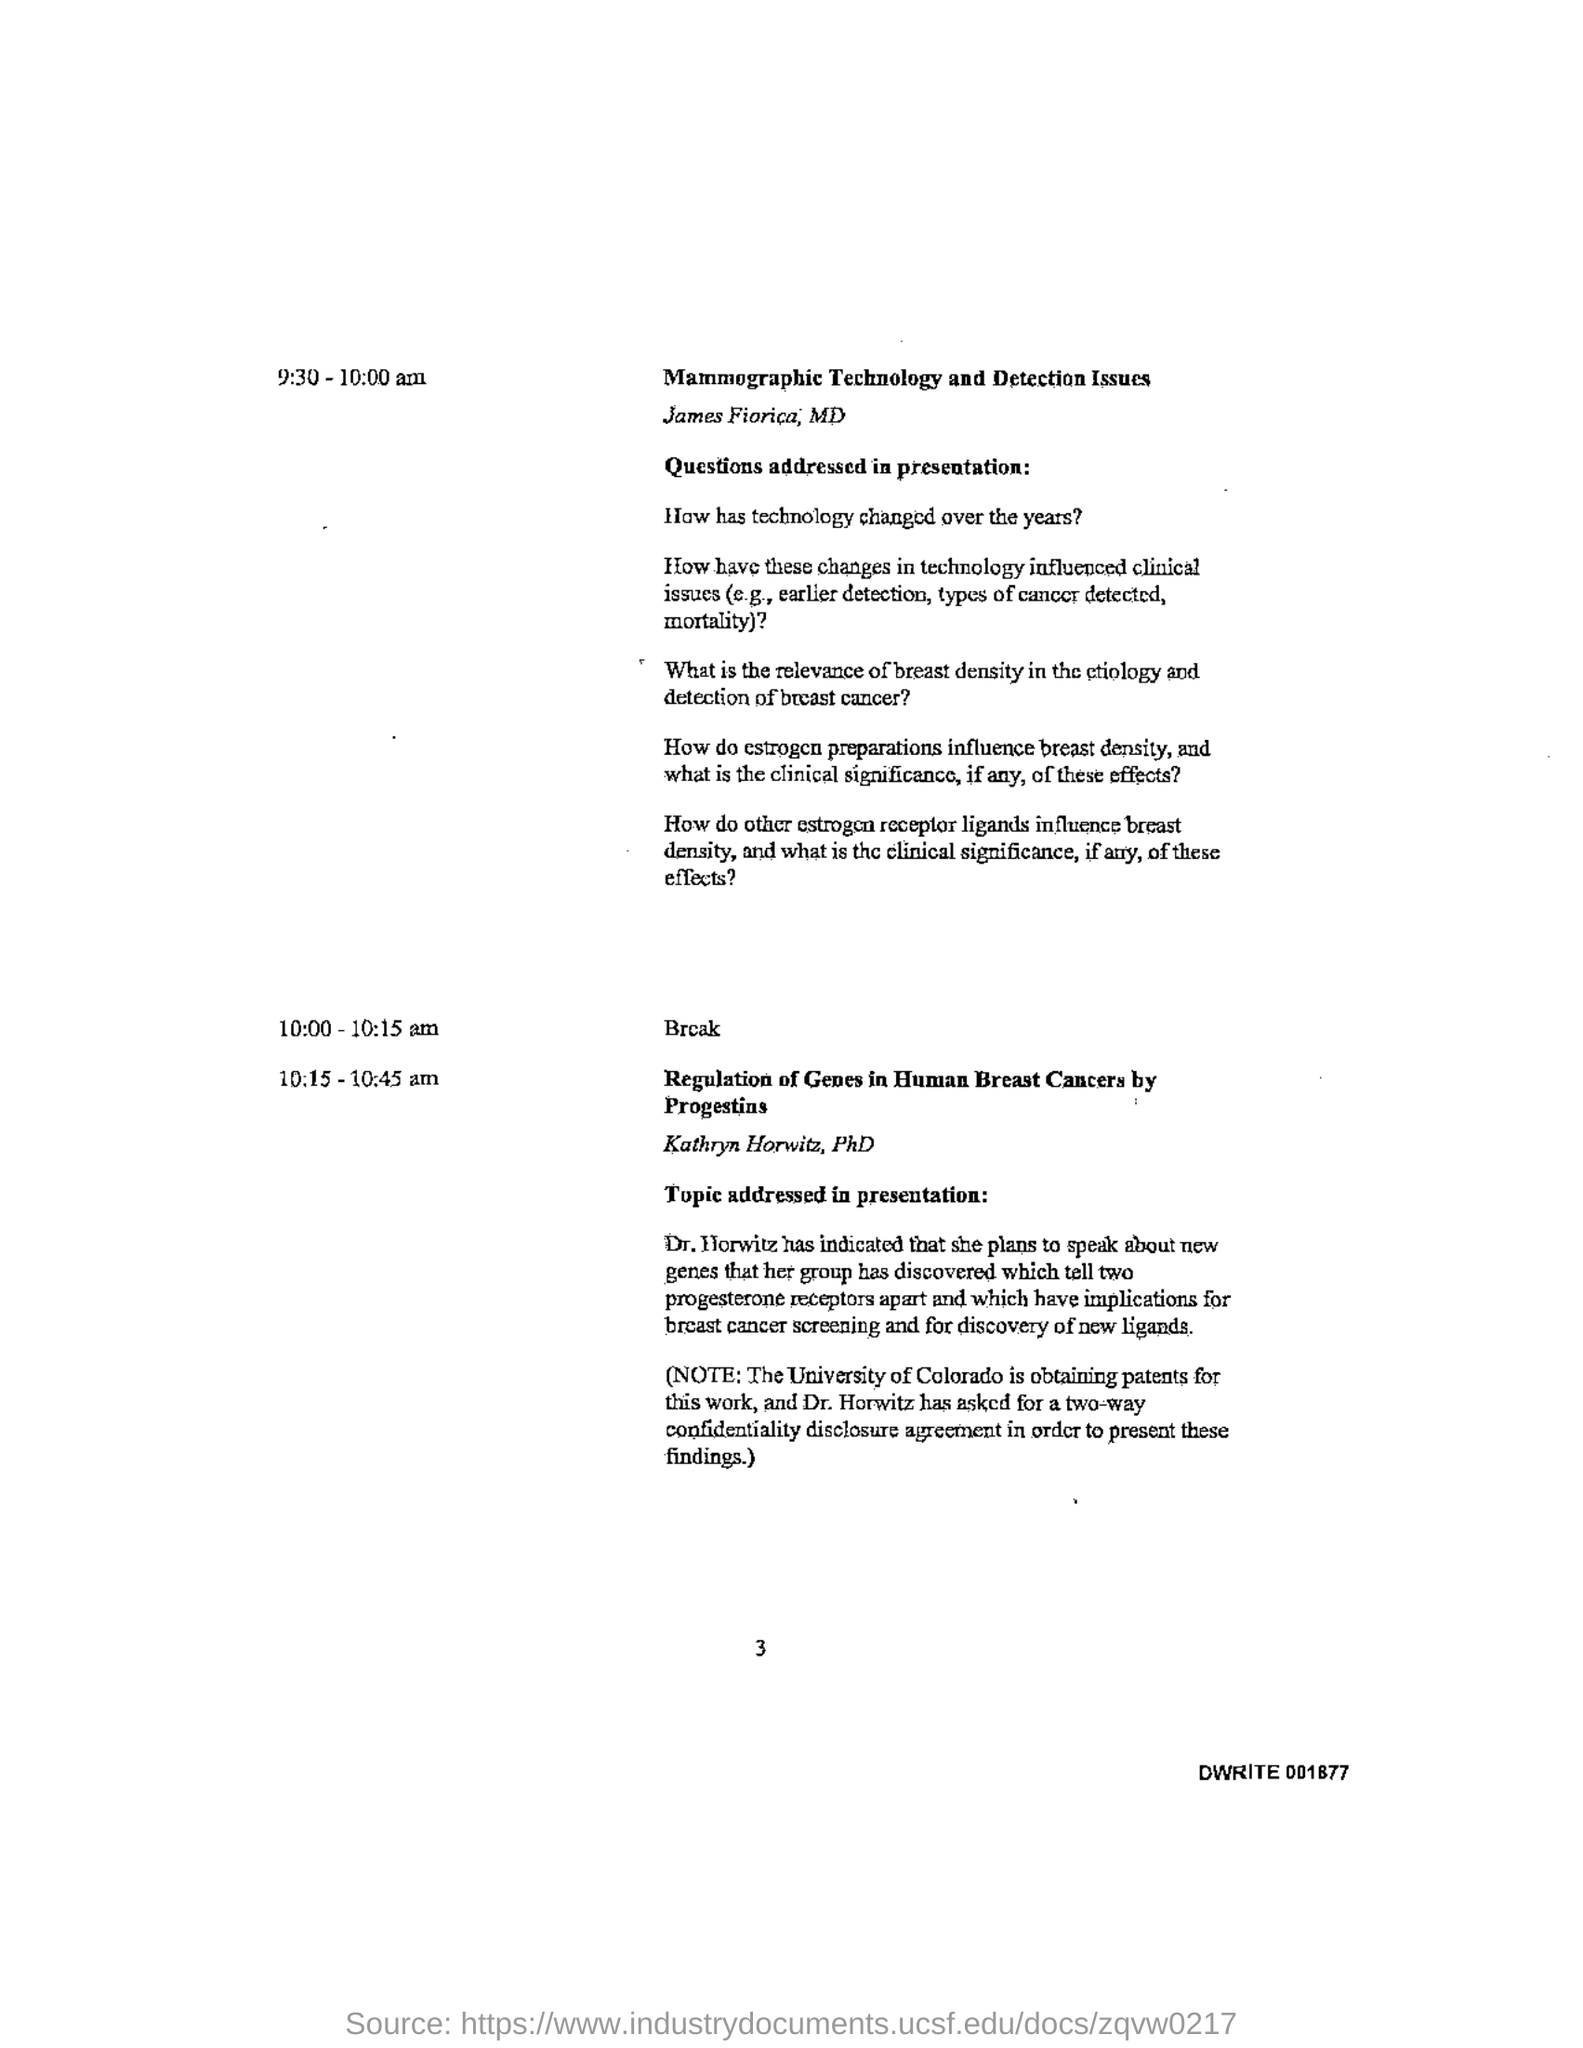Specify some key components in this picture. The alphanumeric sequence located at the right bottom is DWRITE 001877. The break will occur from 10:00-10:15 am. 